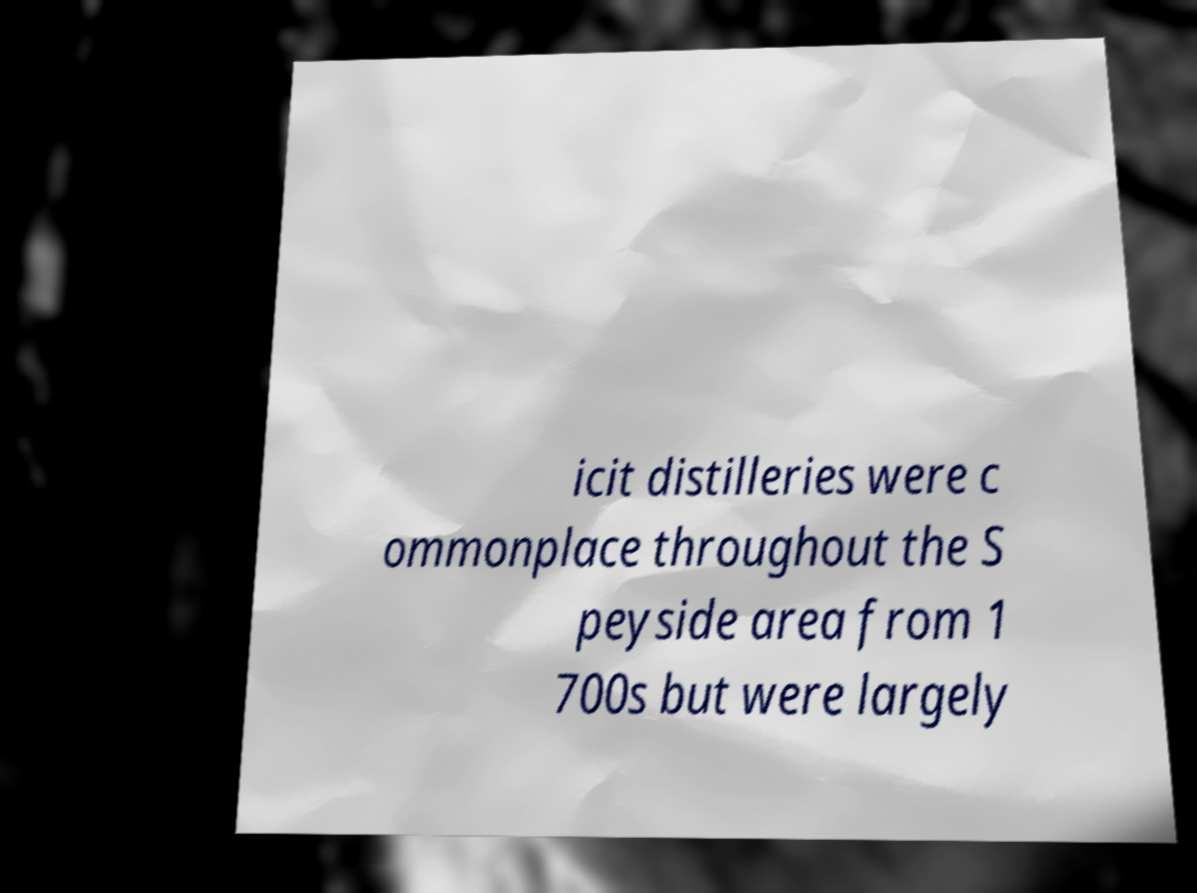There's text embedded in this image that I need extracted. Can you transcribe it verbatim? icit distilleries were c ommonplace throughout the S peyside area from 1 700s but were largely 